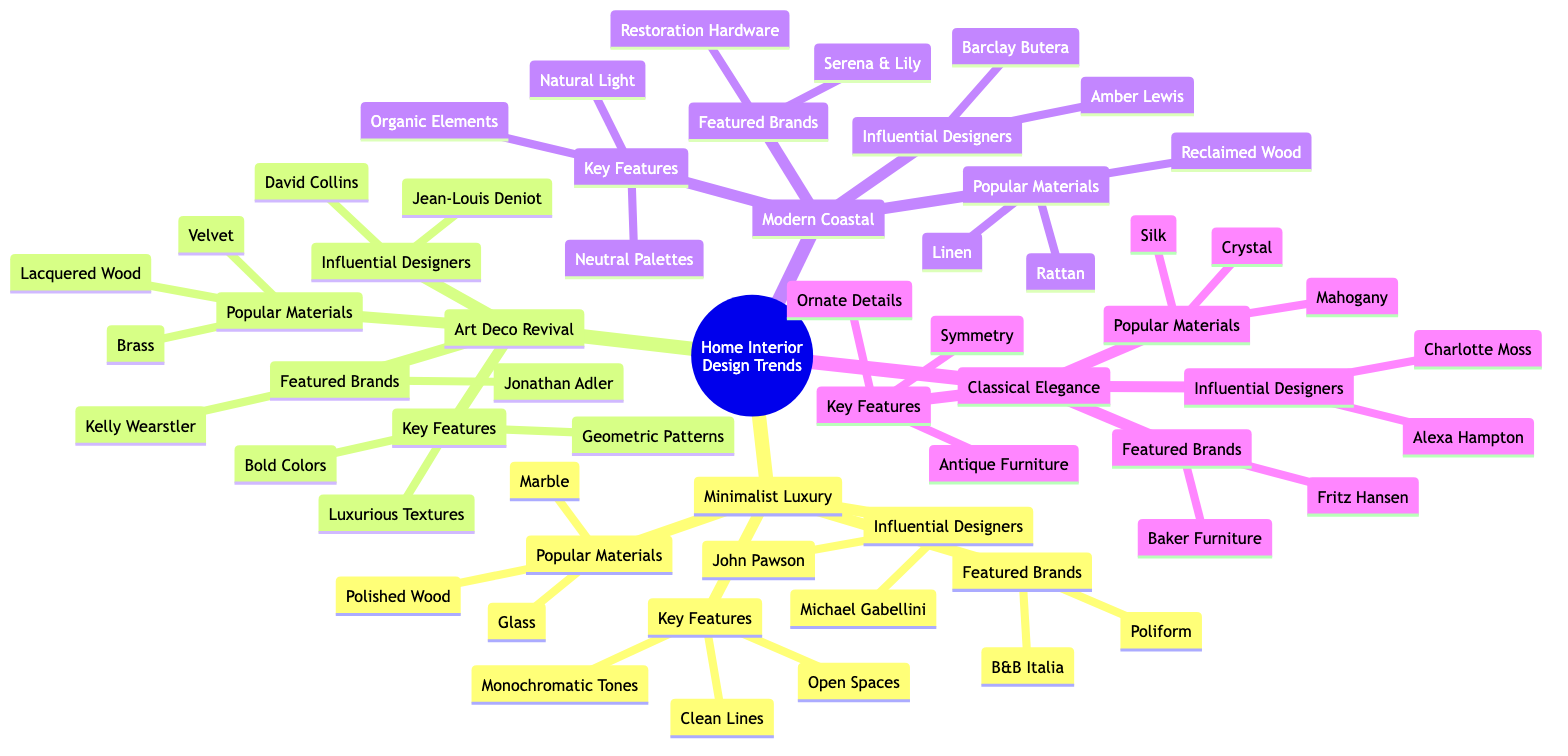What are the key features of Minimalist Luxury? The diagram lists "Clean Lines," "Monochromatic Tones," and "Open Spaces" as the key features for Minimalist Luxury. I find this information by locating the "Minimalist Luxury" node and then looking at its "Key Features" section.
Answer: Clean Lines, Monochromatic Tones, Open Spaces Who are the influential designers of Art Deco Revival? The influential designers for Art Deco Revival are "Jean-Louis Deniot" and "David Collins." I determine this by finding the "Art Deco Revival" node and examining its "Influential Designers" section.
Answer: Jean-Louis Deniot, David Collins What material is common in Modern Coastal design? The popular materials for Modern Coastal include "Rattan," "Linen," and "Reclaimed Wood." I identify this by going to the "Modern Coastal" node and checking under "Popular Materials."
Answer: Rattan, Linen, Reclaimed Wood Which brand is featured under Classical Elegance? The featured brands under Classical Elegance are "Fritz Hansen" and "Baker Furniture." I get this information by navigating to the "Classical Elegance" leaf node and viewing the "Featured Brands" section.
Answer: Fritz Hansen, Baker Furniture What is the total number of influential designers across all styles? Adding up the influential designers listed under each style, we have 2 for Minimalist Luxury, 2 for Art Deco Revival, 2 for Modern Coastal, and 2 for Classical Elegance, resulting in a total of 8. I verify this by counting the designers listed in the "Influential Designers" sections for all four styles.
Answer: 8 Which style emphasizes symmetry? The "Key Features" section for "Classical Elegance" contains "Symmetry." I find this by searching for the features of each style and identifying which one includes symmetry.
Answer: Classical Elegance How many popular materials are listed under the Art Deco Revival? The diagram shows three popular materials, which are "Velvet," "Brass," and "Lacquered Wood." I find this by looking at the "Popular Materials" section under the "Art Deco Revival" node.
Answer: 3 What color scheme is associated with Modern Coastal? The "Key Features" of Modern Coastal highlight "Neutral Palettes," indicating a color scheme focused on neutral tones. I conclude this by checking the "Key Features" section for Modern Coastal.
Answer: Neutral Palettes Which style includes ornate details? "Ornate Details" is a key feature listed under "Classical Elegance." I answer this by reviewing the "Key Features" for each style and spotting which one includes this term.
Answer: Classical Elegance 